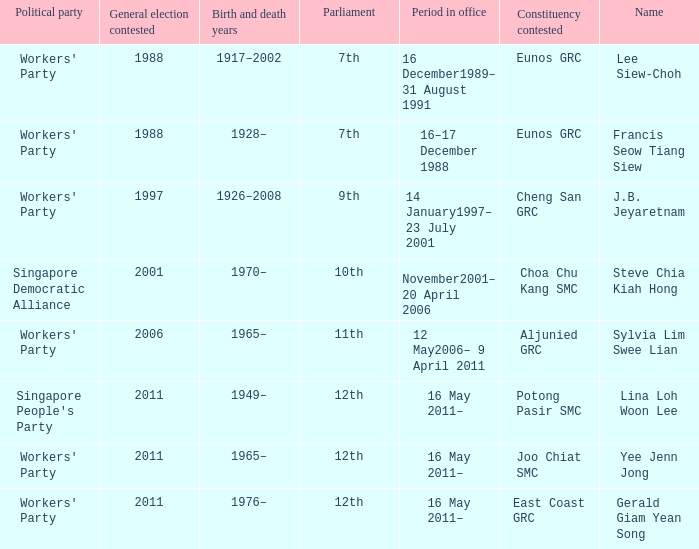Which parliament is sylvia lim swee lian? 11th. 